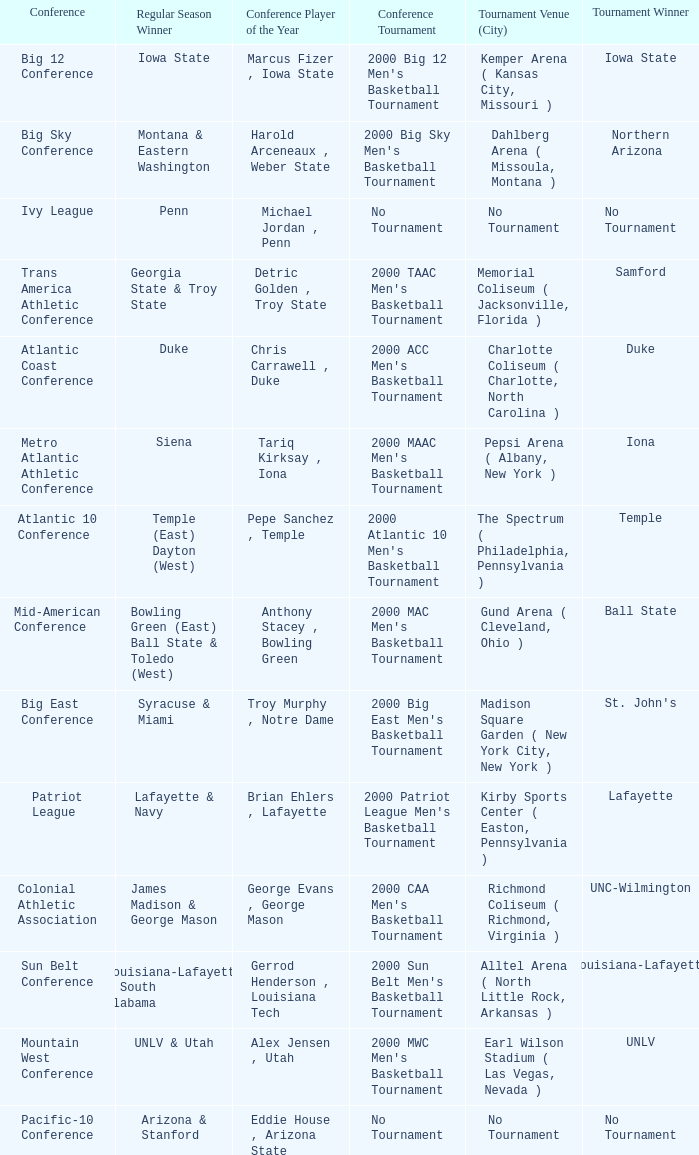How many players of the year are there in the Mountain West Conference? 1.0. 